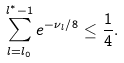Convert formula to latex. <formula><loc_0><loc_0><loc_500><loc_500>\sum _ { l = l _ { 0 } } ^ { l ^ { * } - 1 } e ^ { - \nu _ { l } / 8 } \leq \frac { 1 } { 4 } .</formula> 